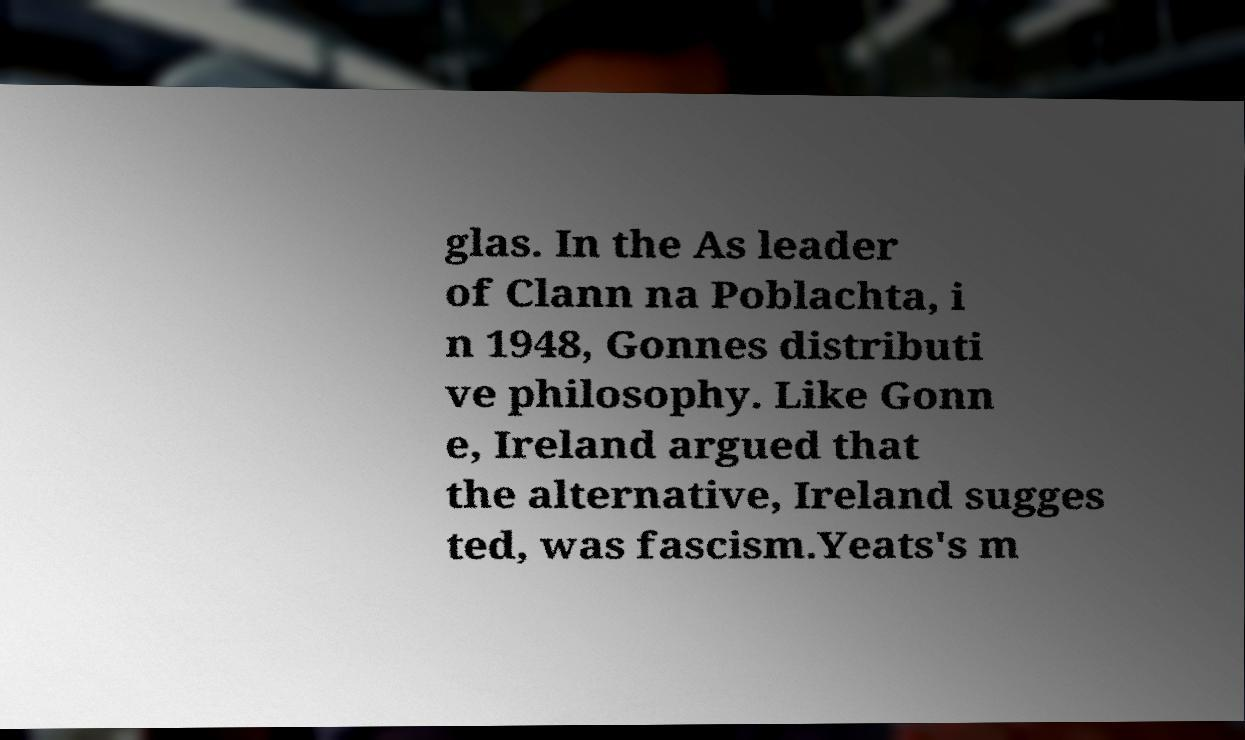Can you read and provide the text displayed in the image?This photo seems to have some interesting text. Can you extract and type it out for me? glas. In the As leader of Clann na Poblachta, i n 1948, Gonnes distributi ve philosophy. Like Gonn e, Ireland argued that the alternative, Ireland sugges ted, was fascism.Yeats's m 